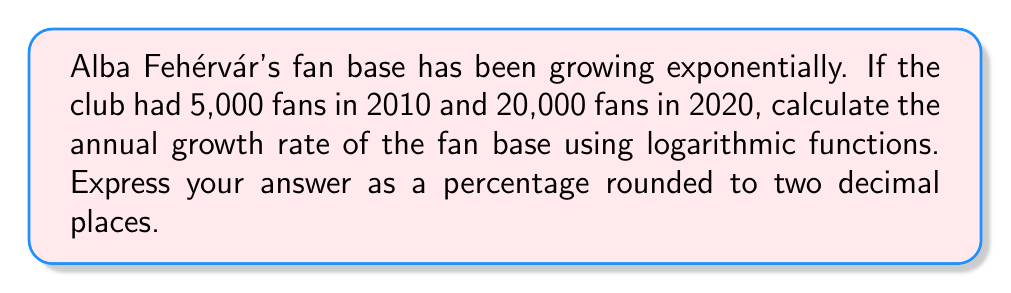Solve this math problem. Let's approach this step-by-step:

1) Let $P_0 = 5,000$ be the initial number of fans in 2010
   Let $P_t = 20,000$ be the number of fans in 2020
   Let $t = 10$ be the number of years
   Let $r$ be the annual growth rate we're solving for

2) The exponential growth formula is:
   $P_t = P_0(1+r)^t$

3) Substituting our known values:
   $20,000 = 5,000(1+r)^{10}$

4) Divide both sides by 5,000:
   $4 = (1+r)^{10}$

5) Take the natural log of both sides:
   $\ln(4) = \ln((1+r)^{10})$

6) Use the logarithm property $\ln(a^b) = b\ln(a)$:
   $\ln(4) = 10\ln(1+r)$

7) Divide both sides by 10:
   $\frac{\ln(4)}{10} = \ln(1+r)$

8) Take $e$ to the power of both sides:
   $e^{\frac{\ln(4)}{10}} = e^{\ln(1+r)} = 1+r$

9) Subtract 1 from both sides:
   $e^{\frac{\ln(4)}{10}} - 1 = r$

10) Calculate:
    $r \approx 0.1486$

11) Convert to percentage:
    $r \approx 14.86\%$
Answer: 14.86% 